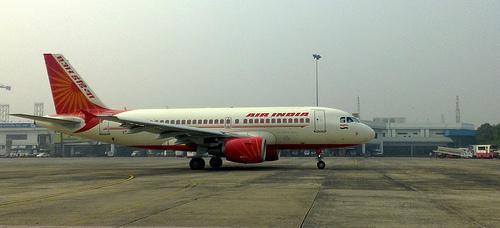How many planes are there?
Give a very brief answer. 1. 